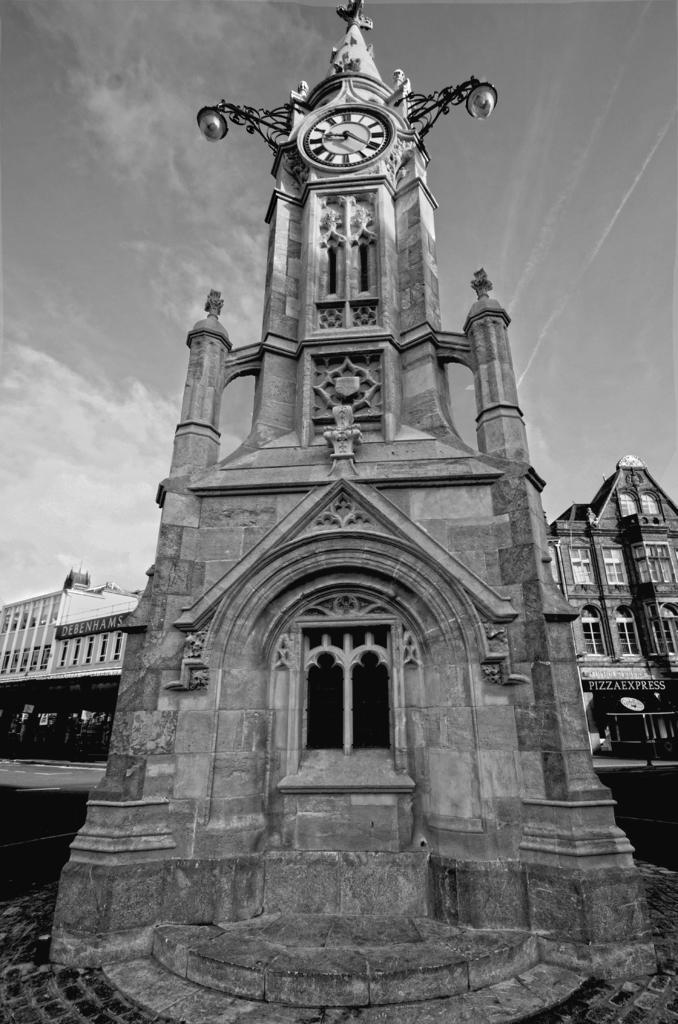How would you summarize this image in a sentence or two? In this image at front there is a church and on top of the church there is a wall clock. In the background there are buildings and sky. 